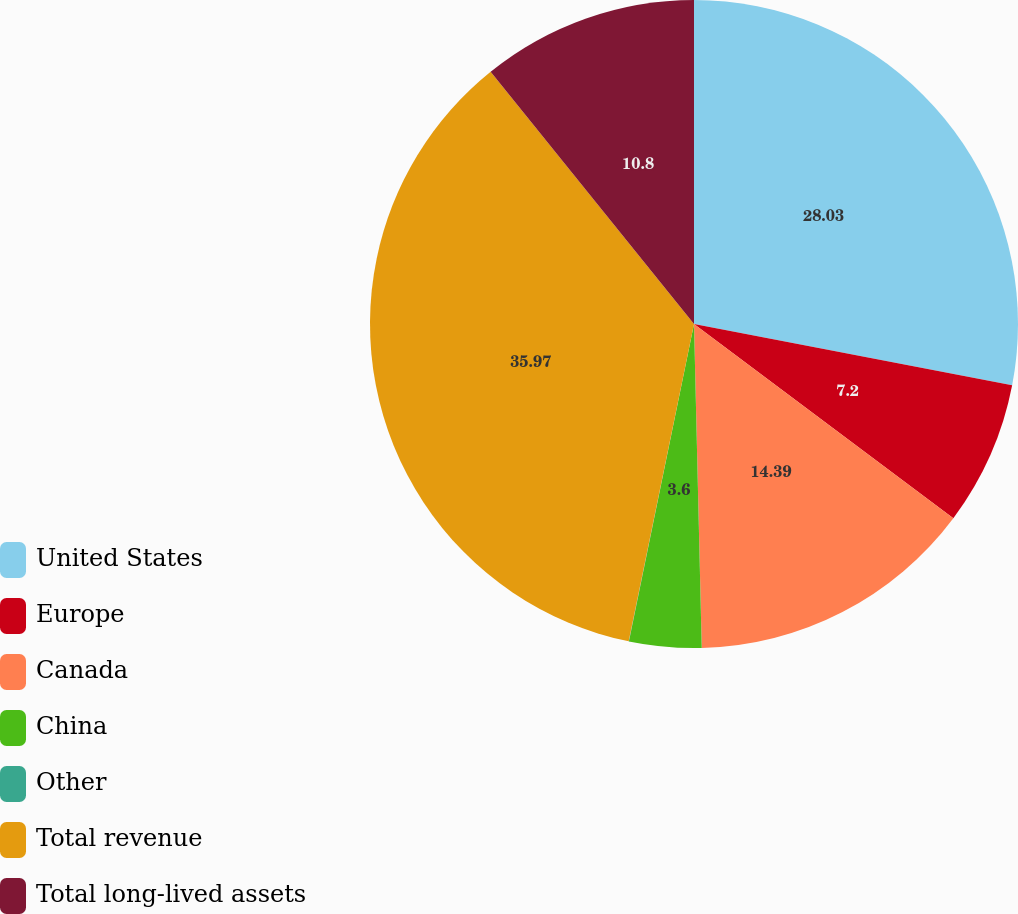<chart> <loc_0><loc_0><loc_500><loc_500><pie_chart><fcel>United States<fcel>Europe<fcel>Canada<fcel>China<fcel>Other<fcel>Total revenue<fcel>Total long-lived assets<nl><fcel>28.03%<fcel>7.2%<fcel>14.39%<fcel>3.6%<fcel>0.01%<fcel>35.97%<fcel>10.8%<nl></chart> 